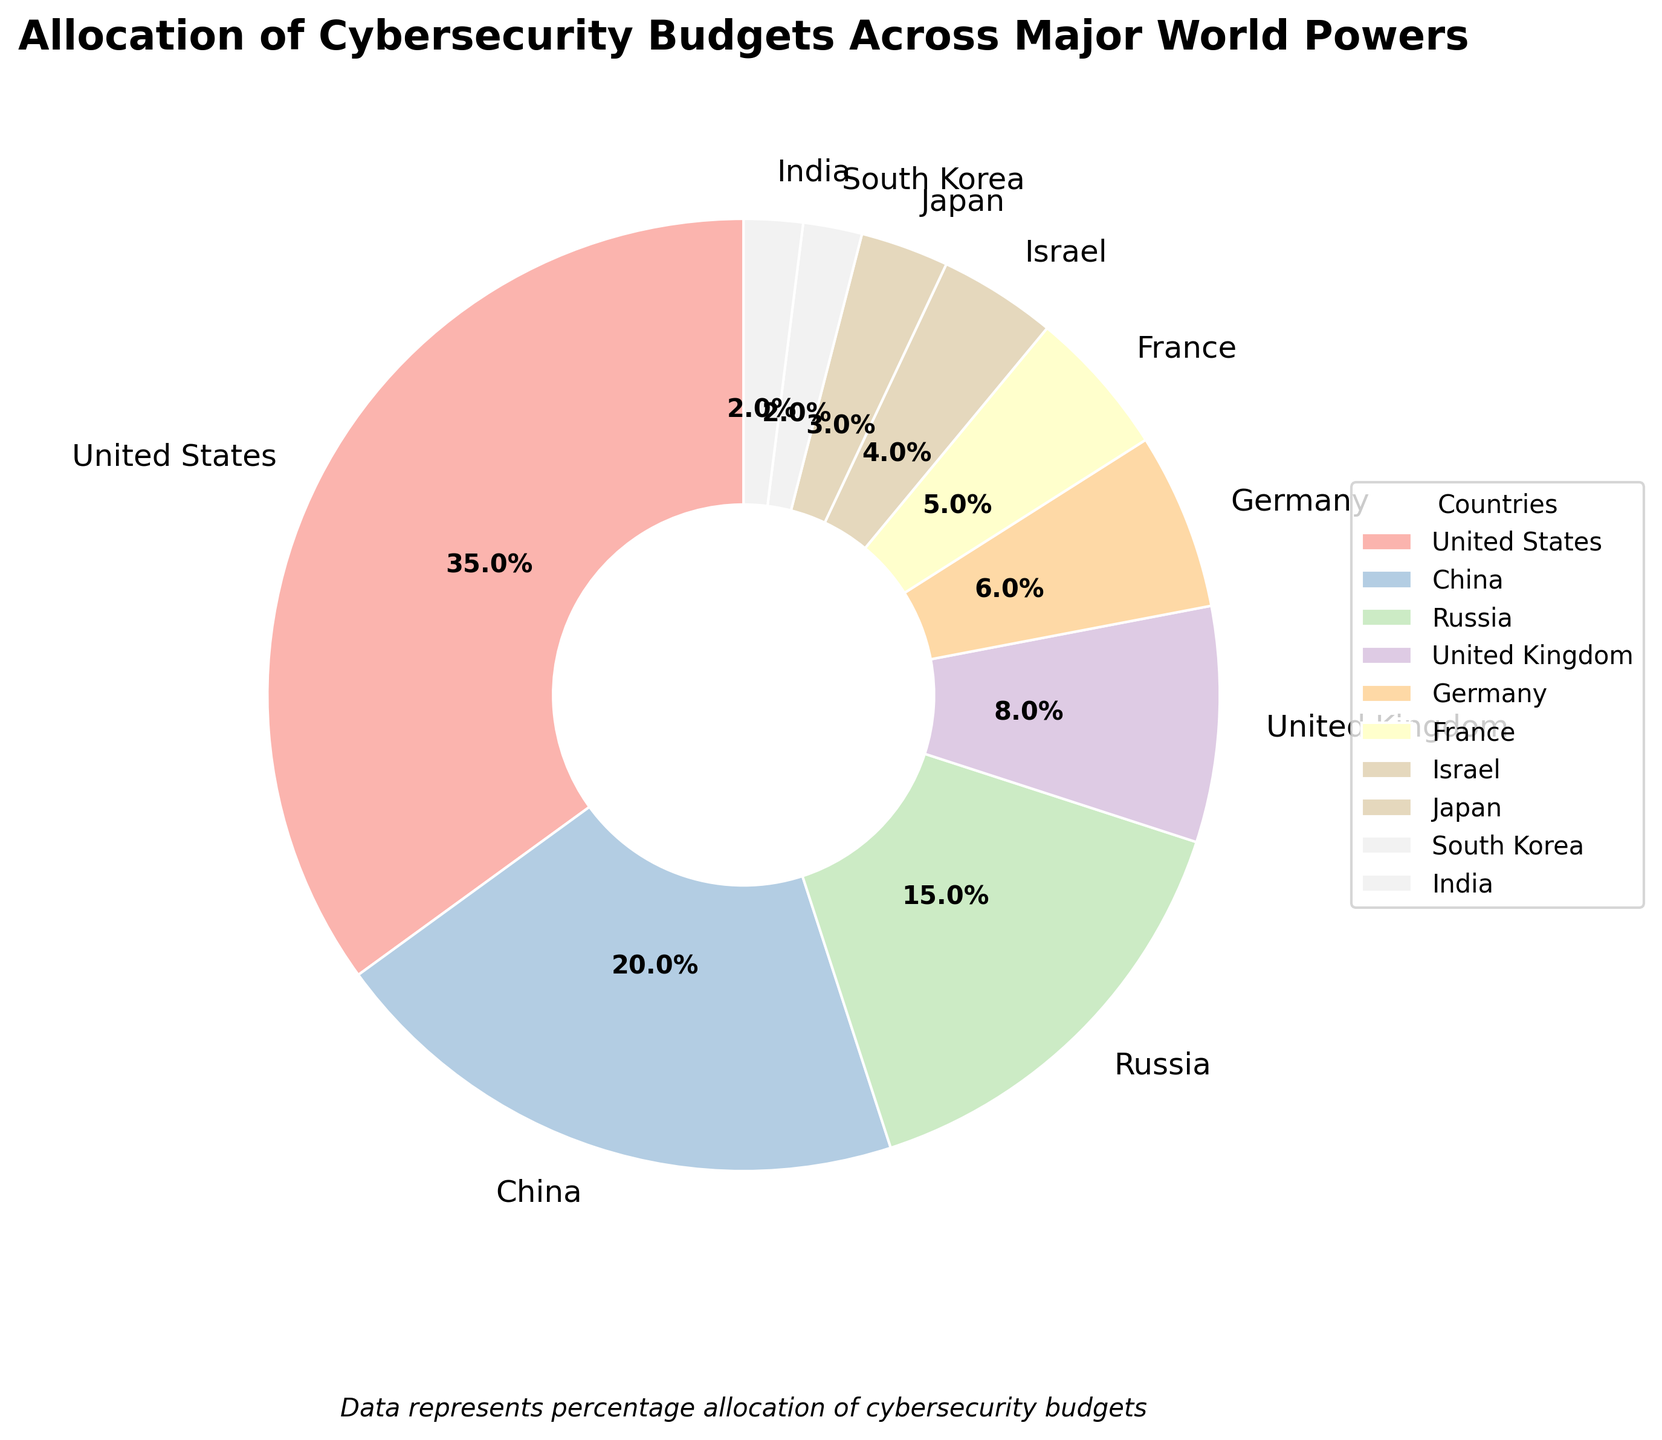Which country allocates the highest percentage of its cybersecurity budget? By observing the pie chart, it's evident that the United States has the largest segment, indicating the highest allocation percentage.
Answer: United States Which countries contribute less than 5% to the total cybersecurity budget? Notice the sections of the pie chart that are labeled with percentages less than 5%. These countries are Israel, Japan, South Korea, and India.
Answer: Israel, Japan, South Korea, India How much more is the United States' allocation compared to China's? The United States allocates 35%. China allocates 20%. The difference is calculated as 35% - 20% = 15%.
Answer: 15% Which two countries have the smallest cybersecurity budget allocations, and what is the combined percentage? Observing the smallest sections of the pie chart, South Korea and India both allocate 2% each. The combined percentage is 2% + 2% = 4%.
Answer: South Korea and India, 4% Comparing the allocations between France and Germany, which country has a larger share and by how much? From the pie chart, Germany allocates 6% and France allocates 5%. The difference is 6% - 5% = 1%.
Answer: Germany, 1% What is the combined cybersecurity budget allocation of the top three countries? The top three countries by percentage are the United States (35%), China (20%), and Russia (15%). The combined allocation is 35% + 20% + 15% = 70%.
Answer: 70% Is the allocation by Israel and Japan together greater than the allocation by the United Kingdom alone? Israel allocates 4% and Japan 3%. Their combined allocation is 4% + 3% = 7%. The United Kingdom alone allocates 8%. So, 7% is less than 8%.
Answer: No If we want to equally distribute the cybersecurity budget among the bottom four countries, how much would each country receive? The bottom four countries are Japan (3%), South Korea (2%), and India (2%), Israel (4%). Their combined total is 3% + 2% + 2% + 4% = 11%. Dividing equally, each would receive 11% / 4 = 2.75%.
Answer: 2.75% What percentage of the budget is allocated by European countries according to the pie chart? European countries listed are the United Kingdom (8%), Germany (6%), and France (5%). Their total allocation is 8% + 6% + 5% = 19%.
Answer: 19% 